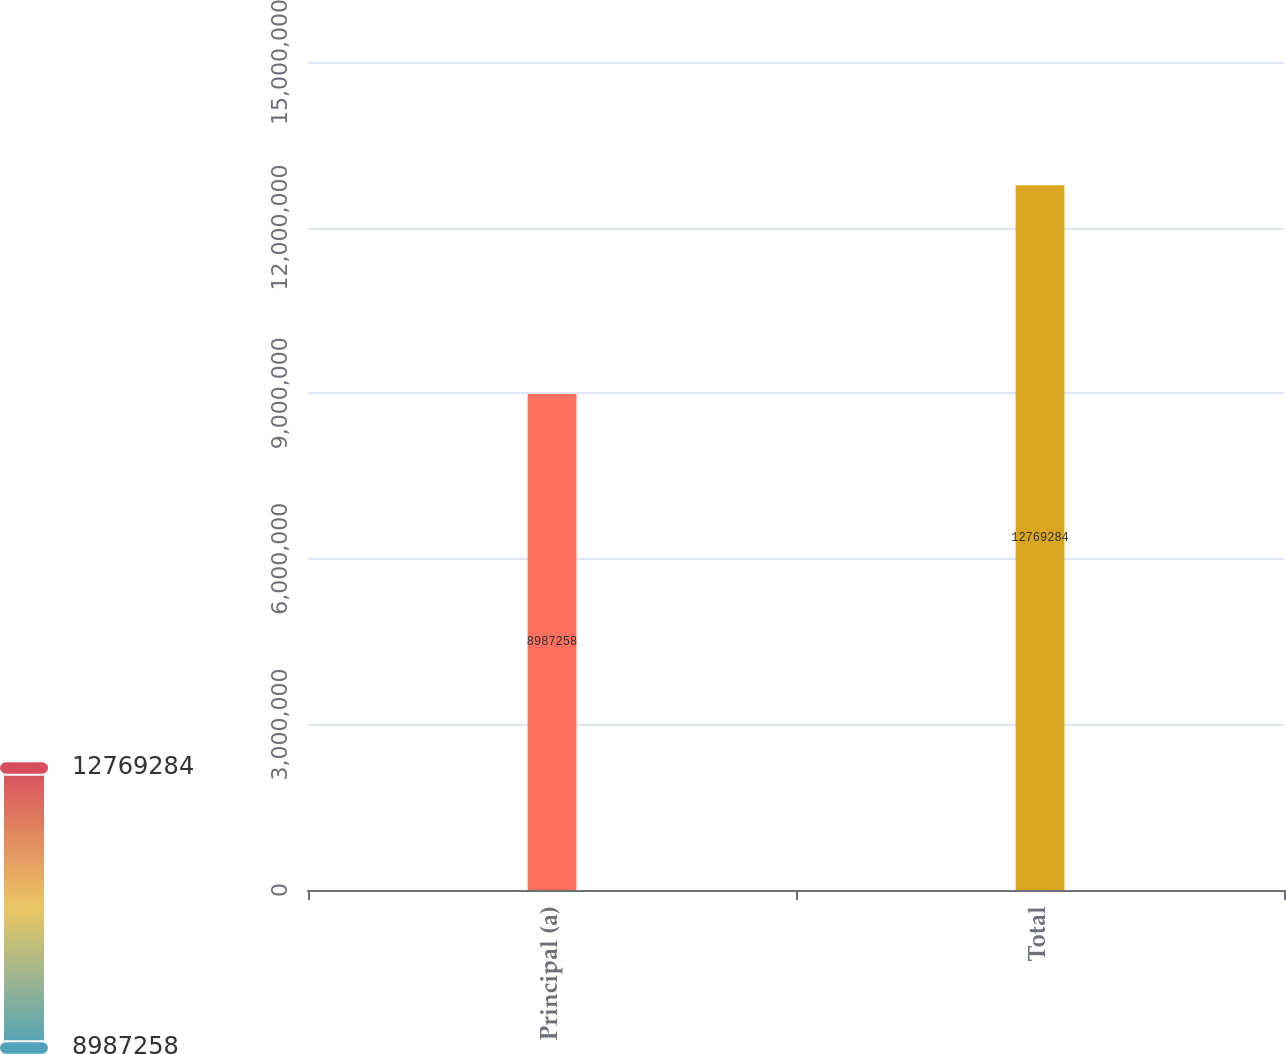Convert chart to OTSL. <chart><loc_0><loc_0><loc_500><loc_500><bar_chart><fcel>Principal (a)<fcel>Total<nl><fcel>8.98726e+06<fcel>1.27693e+07<nl></chart> 